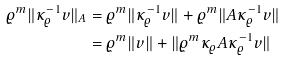<formula> <loc_0><loc_0><loc_500><loc_500>\varrho ^ { m } \| \kappa _ { \varrho } ^ { - 1 } v \| _ { A } & = \varrho ^ { m } \| \kappa _ { \varrho } ^ { - 1 } v \| + \varrho ^ { m } \| A \kappa _ { \varrho } ^ { - 1 } v \| \\ & = \varrho ^ { m } \| v \| + \| \varrho ^ { m } \kappa _ { \varrho } A \kappa _ { \varrho } ^ { - 1 } v \|</formula> 